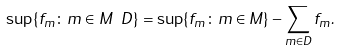<formula> <loc_0><loc_0><loc_500><loc_500>\sup \{ f _ { m } \colon m \in M \ D \} = \sup \{ f _ { m } \colon m \in M \} - \sum _ { m \in D } f _ { m } .</formula> 